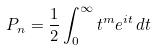Convert formula to latex. <formula><loc_0><loc_0><loc_500><loc_500>P _ { n } = \frac { 1 } { 2 } \int _ { 0 } ^ { \infty } t ^ { m } e ^ { i t } \, d t</formula> 